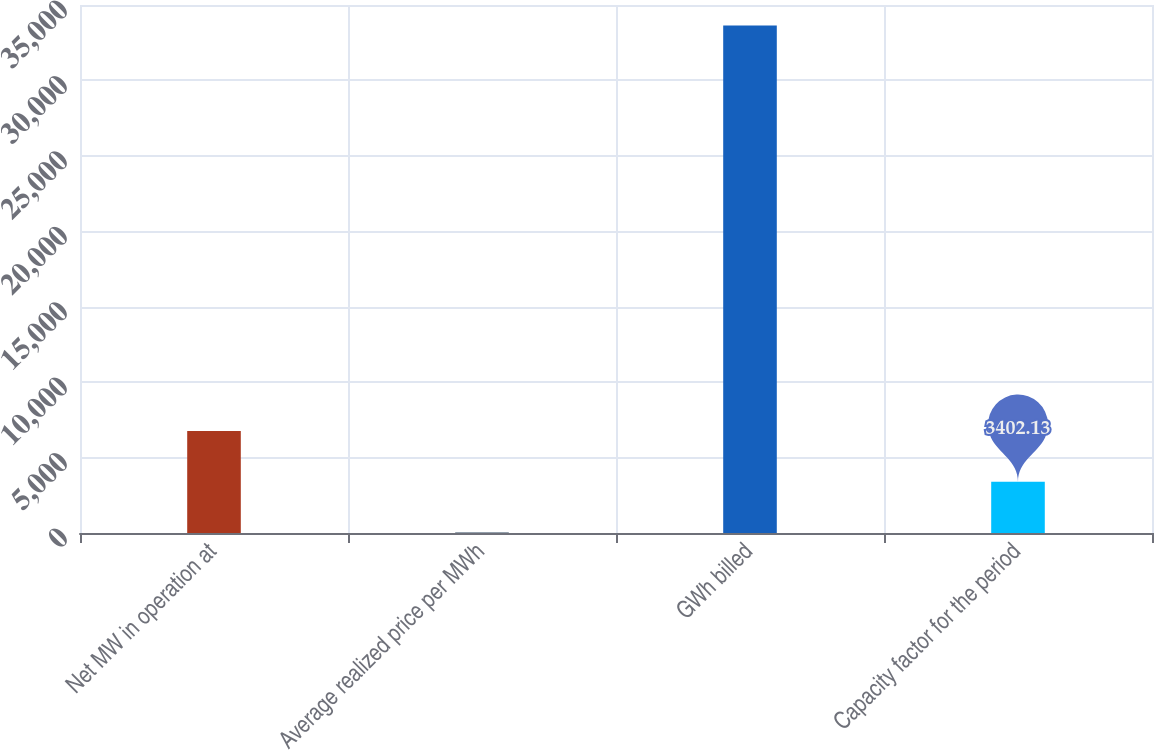Convert chart. <chart><loc_0><loc_0><loc_500><loc_500><bar_chart><fcel>Net MW in operation at<fcel>Average realized price per MWh<fcel>GWh billed<fcel>Capacity factor for the period<nl><fcel>6762<fcel>42.26<fcel>33641<fcel>3402.13<nl></chart> 